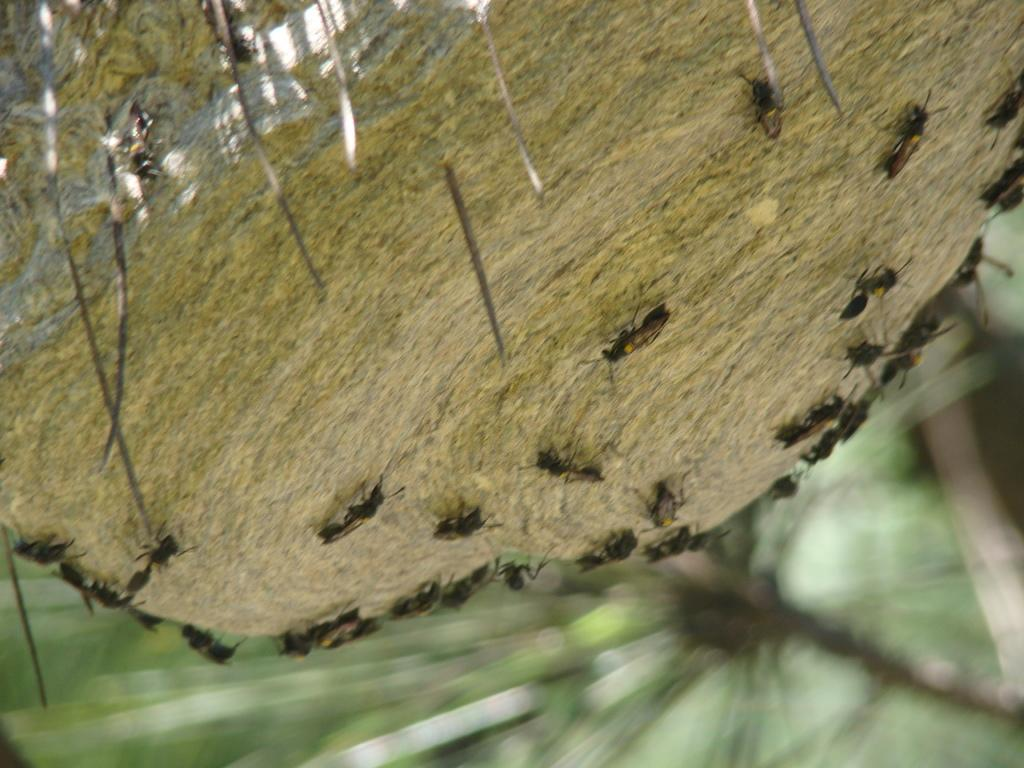What is the main subject of the image? There is a group of insects on a rock in the image. What can be seen in the background of the image? There are trees visible in the background of the image. How would you describe the background of the image? The background appears blurry. What type of car is parked near the insects in the image? There is no car present in the image; it features a group of insects on a rock with trees visible in the background. 